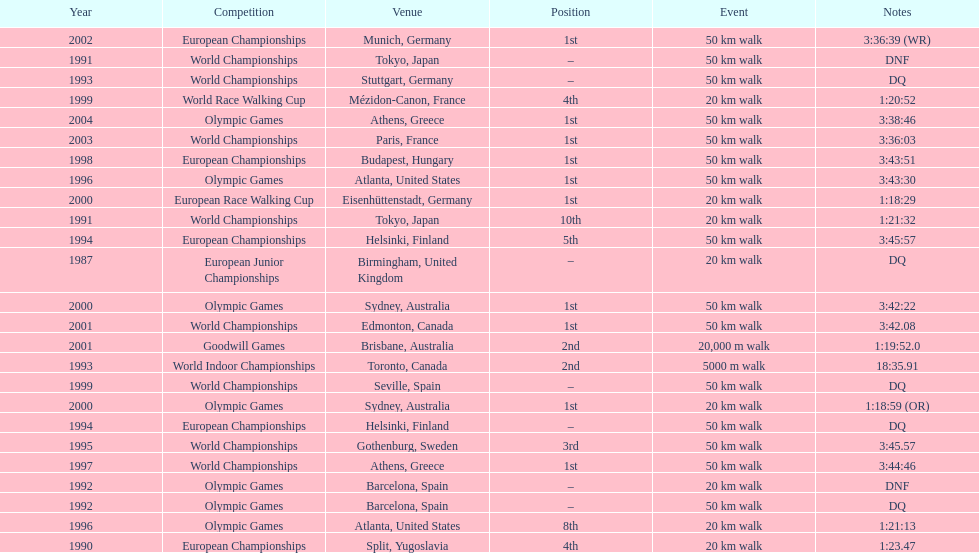How many times did korzeniowski finish above fourth place? 13. I'm looking to parse the entire table for insights. Could you assist me with that? {'header': ['Year', 'Competition', 'Venue', 'Position', 'Event', 'Notes'], 'rows': [['2002', 'European Championships', 'Munich, Germany', '1st', '50\xa0km walk', '3:36:39 (WR)'], ['1991', 'World Championships', 'Tokyo, Japan', '–', '50\xa0km walk', 'DNF'], ['1993', 'World Championships', 'Stuttgart, Germany', '–', '50\xa0km walk', 'DQ'], ['1999', 'World Race Walking Cup', 'Mézidon-Canon, France', '4th', '20\xa0km walk', '1:20:52'], ['2004', 'Olympic Games', 'Athens, Greece', '1st', '50\xa0km walk', '3:38:46'], ['2003', 'World Championships', 'Paris, France', '1st', '50\xa0km walk', '3:36:03'], ['1998', 'European Championships', 'Budapest, Hungary', '1st', '50\xa0km walk', '3:43:51'], ['1996', 'Olympic Games', 'Atlanta, United States', '1st', '50\xa0km walk', '3:43:30'], ['2000', 'European Race Walking Cup', 'Eisenhüttenstadt, Germany', '1st', '20\xa0km walk', '1:18:29'], ['1991', 'World Championships', 'Tokyo, Japan', '10th', '20\xa0km walk', '1:21:32'], ['1994', 'European Championships', 'Helsinki, Finland', '5th', '50\xa0km walk', '3:45:57'], ['1987', 'European Junior Championships', 'Birmingham, United Kingdom', '–', '20\xa0km walk', 'DQ'], ['2000', 'Olympic Games', 'Sydney, Australia', '1st', '50\xa0km walk', '3:42:22'], ['2001', 'World Championships', 'Edmonton, Canada', '1st', '50\xa0km walk', '3:42.08'], ['2001', 'Goodwill Games', 'Brisbane, Australia', '2nd', '20,000 m walk', '1:19:52.0'], ['1993', 'World Indoor Championships', 'Toronto, Canada', '2nd', '5000 m walk', '18:35.91'], ['1999', 'World Championships', 'Seville, Spain', '–', '50\xa0km walk', 'DQ'], ['2000', 'Olympic Games', 'Sydney, Australia', '1st', '20\xa0km walk', '1:18:59 (OR)'], ['1994', 'European Championships', 'Helsinki, Finland', '–', '50\xa0km walk', 'DQ'], ['1995', 'World Championships', 'Gothenburg, Sweden', '3rd', '50\xa0km walk', '3:45.57'], ['1997', 'World Championships', 'Athens, Greece', '1st', '50\xa0km walk', '3:44:46'], ['1992', 'Olympic Games', 'Barcelona, Spain', '–', '20\xa0km walk', 'DNF'], ['1992', 'Olympic Games', 'Barcelona, Spain', '–', '50\xa0km walk', 'DQ'], ['1996', 'Olympic Games', 'Atlanta, United States', '8th', '20\xa0km walk', '1:21:13'], ['1990', 'European Championships', 'Split, Yugoslavia', '4th', '20\xa0km walk', '1:23.47']]} 